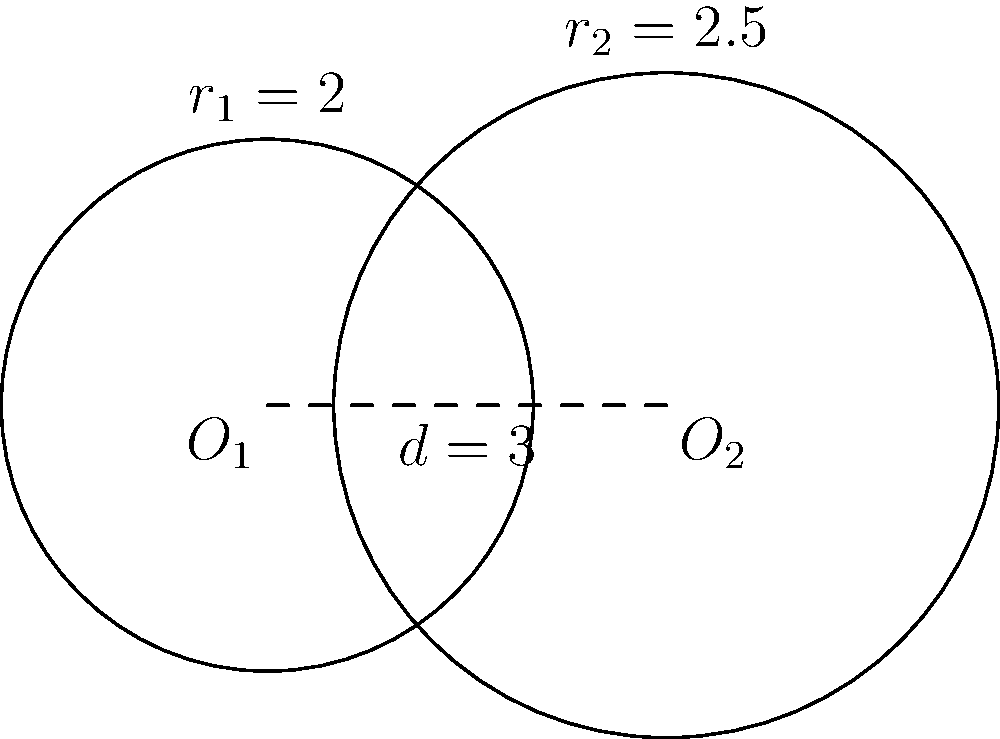In a cultural exchange program, two groups of students from different countries form circles during an icebreaker activity. The centers of the circles are 3 meters apart. One circle has a radius of 2 meters, while the other has a radius of 2.5 meters. Calculate the area of the region where the two circles overlap, representing the space where intercultural dialogue occurs. Round your answer to two decimal places. To find the area of overlap between two intersecting circles, we'll use the following steps:

1) First, we need to calculate the distance $x$ from the center of each circle to the line of intersection. We can use the formula:

   $$x_1 = \frac{r_1^2 - r_2^2 + d^2}{2d}$$
   $$x_2 = d - x_1$$

   Where $r_1 = 2$, $r_2 = 2.5$, and $d = 3$

2) Calculate $x_1$:
   $$x_1 = \frac{2^2 - 2.5^2 + 3^2}{2(3)} = \frac{4 - 6.25 + 9}{6} = \frac{6.75}{6} = 1.125$$

3) Calculate $x_2$:
   $$x_2 = 3 - 1.125 = 1.875$$

4) Now, we can calculate the height $h$ of the triangle formed:
   $$h = \sqrt{r_1^2 - x_1^2} = \sqrt{2^2 - 1.125^2} = \sqrt{4 - 1.265625} = \sqrt{2.734375} = 1.65362$$

5) The area of overlap is given by the formula:
   $$A = r_1^2 \arccos(\frac{x_1}{r_1}) + r_2^2 \arccos(\frac{x_2}{r_2}) - d\sqrt{r_1^2 - x_1^2}$$

6) Substituting the values:
   $$A = 2^2 \arccos(\frac{1.125}{2}) + 2.5^2 \arccos(\frac{1.875}{2.5}) - 3\sqrt{2^2 - 1.125^2}$$
   $$A = 4 \arccos(0.5625) + 6.25 \arccos(0.75) - 3(1.65362)$$
   $$A = 4(0.9775) + 6.25(0.7227) - 4.96086$$
   $$A = 3.91 + 4.52 - 4.96 = 3.47$$

7) Rounding to two decimal places:
   $$A \approx 3.47 \text{ square meters}$$
Answer: 3.47 square meters 